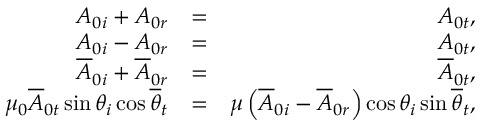Convert formula to latex. <formula><loc_0><loc_0><loc_500><loc_500>\begin{array} { r l r } { A _ { 0 i } + A _ { 0 r } } & { = } & { A _ { 0 t } , } \\ { A _ { 0 i } - A _ { 0 r } } & { = } & { A _ { 0 t } , } \\ { \overline { A } _ { 0 i } + \overline { A } _ { 0 r } } & { = } & { \overline { A } _ { 0 t } , } \\ { \mu _ { 0 } \overline { A } _ { 0 t } \sin \theta _ { i } \cos \overline { \theta } _ { t } } & { = } & { \mu \left ( \overline { A } _ { 0 i } - \overline { A } _ { 0 r } \right ) \cos \theta _ { i } \sin \overline { \theta } _ { t } , } \end{array}</formula> 